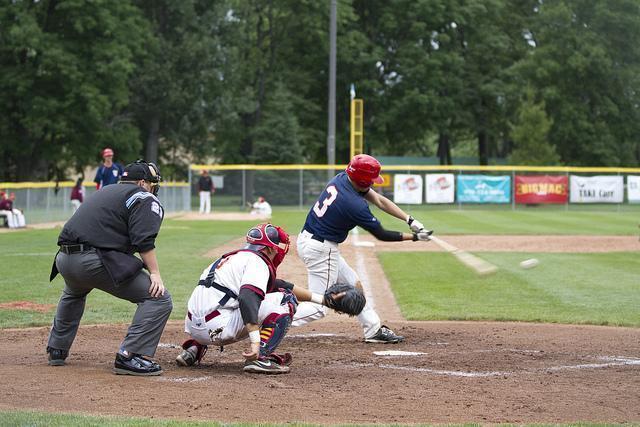What happens in the ball goes over the yellow barrier?
Choose the correct response, then elucidate: 'Answer: answer
Rationale: rationale.'
Options: Walk, strike, home run, run. Answer: home run.
Rationale: The person will make a homerun. 